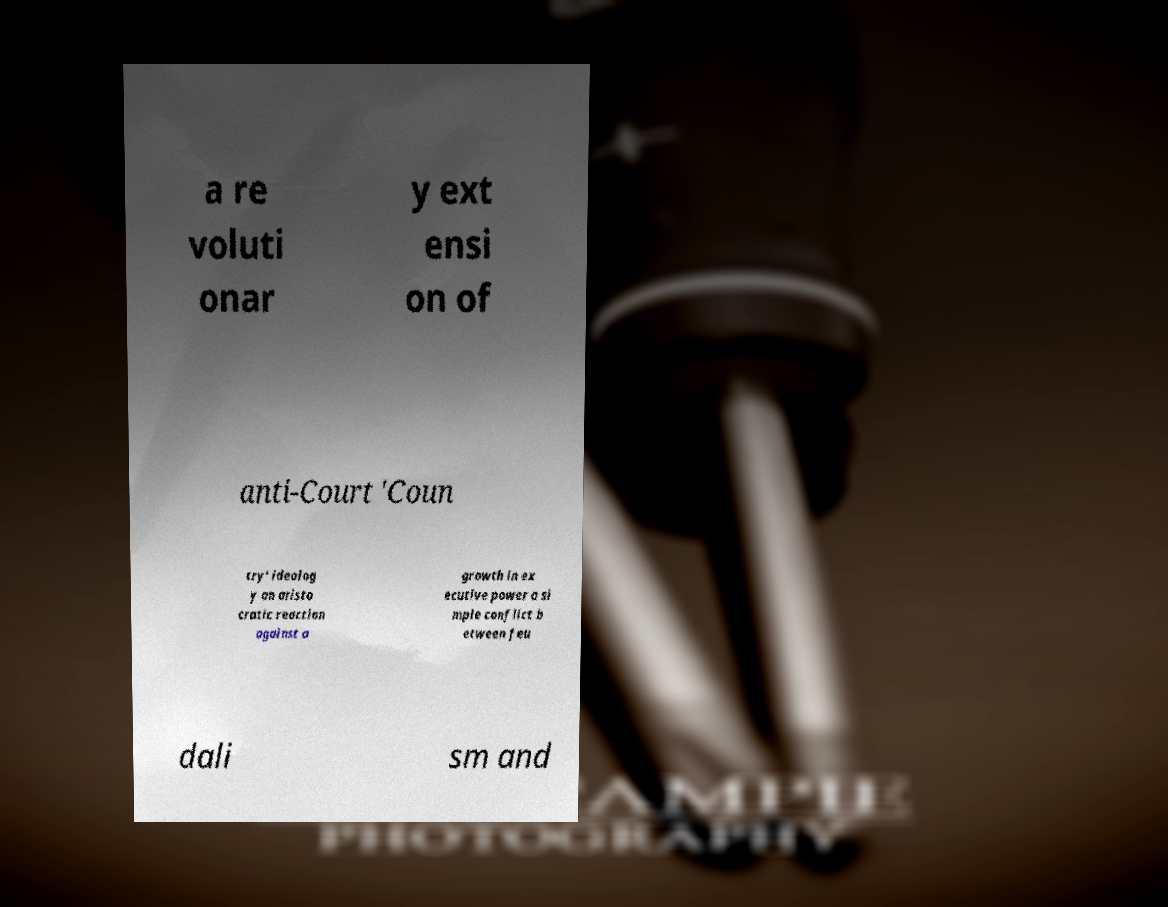There's text embedded in this image that I need extracted. Can you transcribe it verbatim? a re voluti onar y ext ensi on of anti-Court 'Coun try' ideolog y an aristo cratic reaction against a growth in ex ecutive power a si mple conflict b etween feu dali sm and 